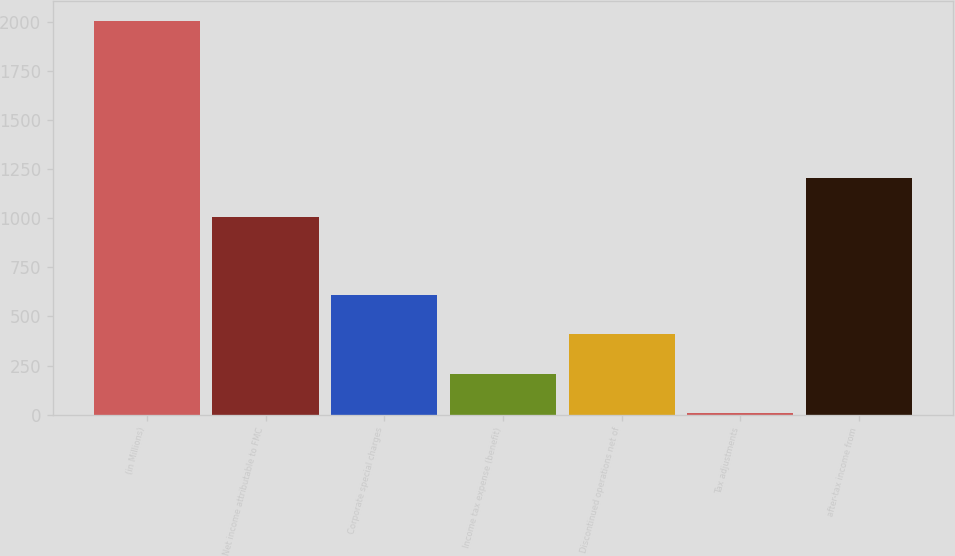Convert chart to OTSL. <chart><loc_0><loc_0><loc_500><loc_500><bar_chart><fcel>(in Millions)<fcel>Net income attributable to FMC<fcel>Corporate special charges<fcel>Income tax expense (benefit)<fcel>Discontinued operations net of<fcel>Tax adjustments<fcel>after-tax income from<nl><fcel>2008<fcel>1008.35<fcel>608.49<fcel>208.63<fcel>408.56<fcel>8.7<fcel>1208.28<nl></chart> 